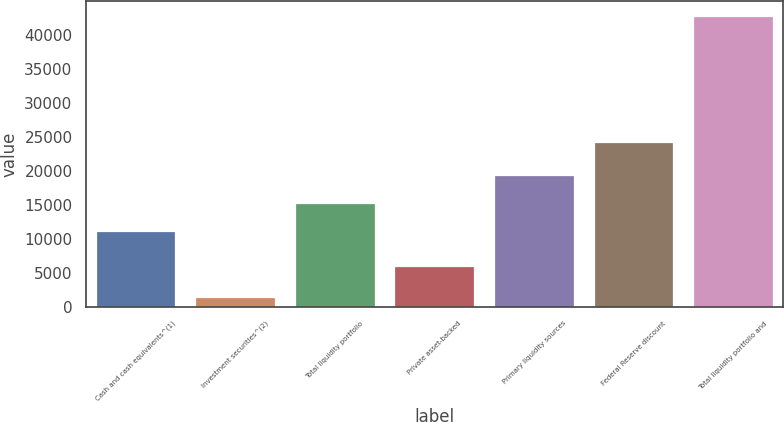Convert chart. <chart><loc_0><loc_0><loc_500><loc_500><bar_chart><fcel>Cash and cash equivalents^(1)<fcel>Investment securities^(2)<fcel>Total liquidity portfolio<fcel>Private asset-backed<fcel>Primary liquidity sources<fcel>Federal Reserve discount<fcel>Total liquidity portfolio and<nl><fcel>11103<fcel>1532<fcel>15232.7<fcel>6000<fcel>19362.4<fcel>24194<fcel>42829<nl></chart> 